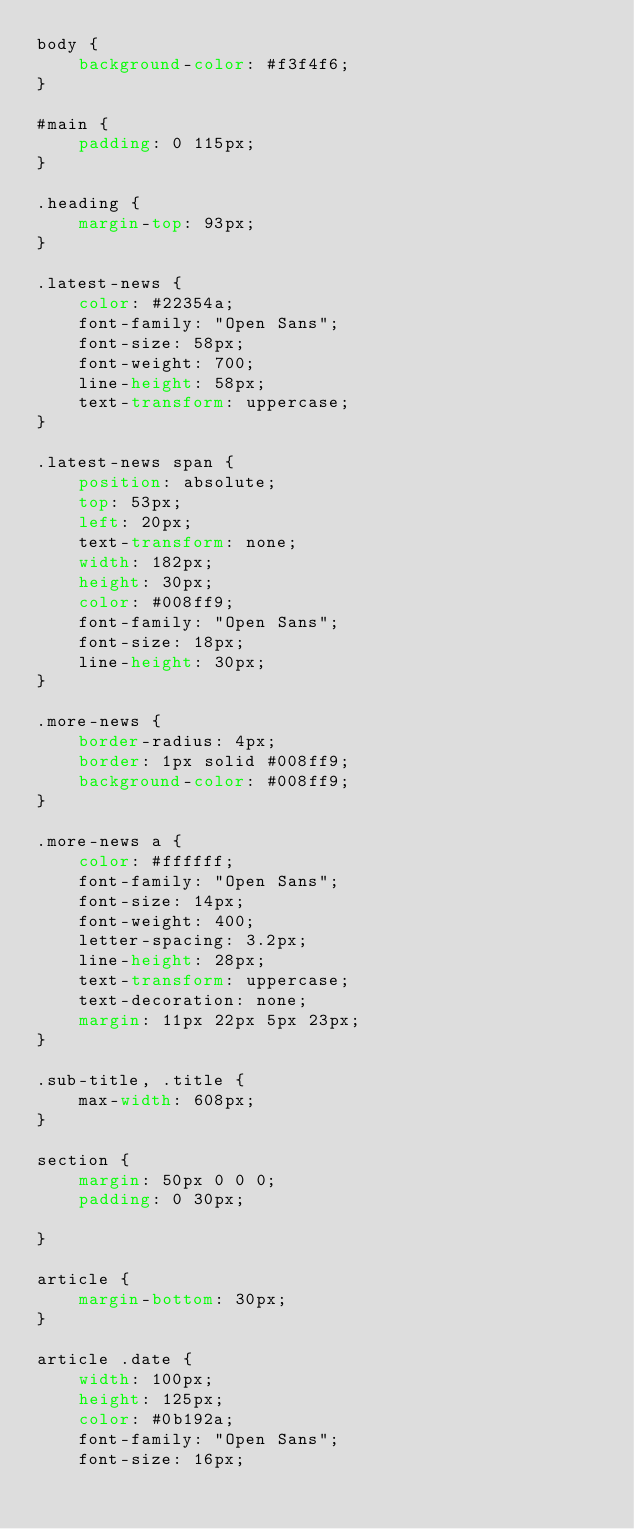<code> <loc_0><loc_0><loc_500><loc_500><_CSS_>body {
    background-color: #f3f4f6;
}

#main {
    padding: 0 115px;
}

.heading {
    margin-top: 93px;
}

.latest-news {
    color: #22354a;
    font-family: "Open Sans";
    font-size: 58px;
    font-weight: 700;
    line-height: 58px;
    text-transform: uppercase;
}

.latest-news span {
    position: absolute;
    top: 53px;
    left: 20px;
    text-transform: none;
    width: 182px;
    height: 30px;
    color: #008ff9;
    font-family: "Open Sans";
    font-size: 18px;
    line-height: 30px;
}

.more-news {
    border-radius: 4px;
    border: 1px solid #008ff9;
    background-color: #008ff9;
}

.more-news a {
    color: #ffffff;
    font-family: "Open Sans";
    font-size: 14px;
    font-weight: 400;
    letter-spacing: 3.2px;
    line-height: 28px;
    text-transform: uppercase;
    text-decoration: none;
    margin: 11px 22px 5px 23px;
}

.sub-title, .title {
    max-width: 608px;
}

section {
    margin: 50px 0 0 0;
    padding: 0 30px;

}

article {
    margin-bottom: 30px;
}

article .date {
    width: 100px;
    height: 125px;
    color: #0b192a;
    font-family: "Open Sans";
    font-size: 16px;</code> 